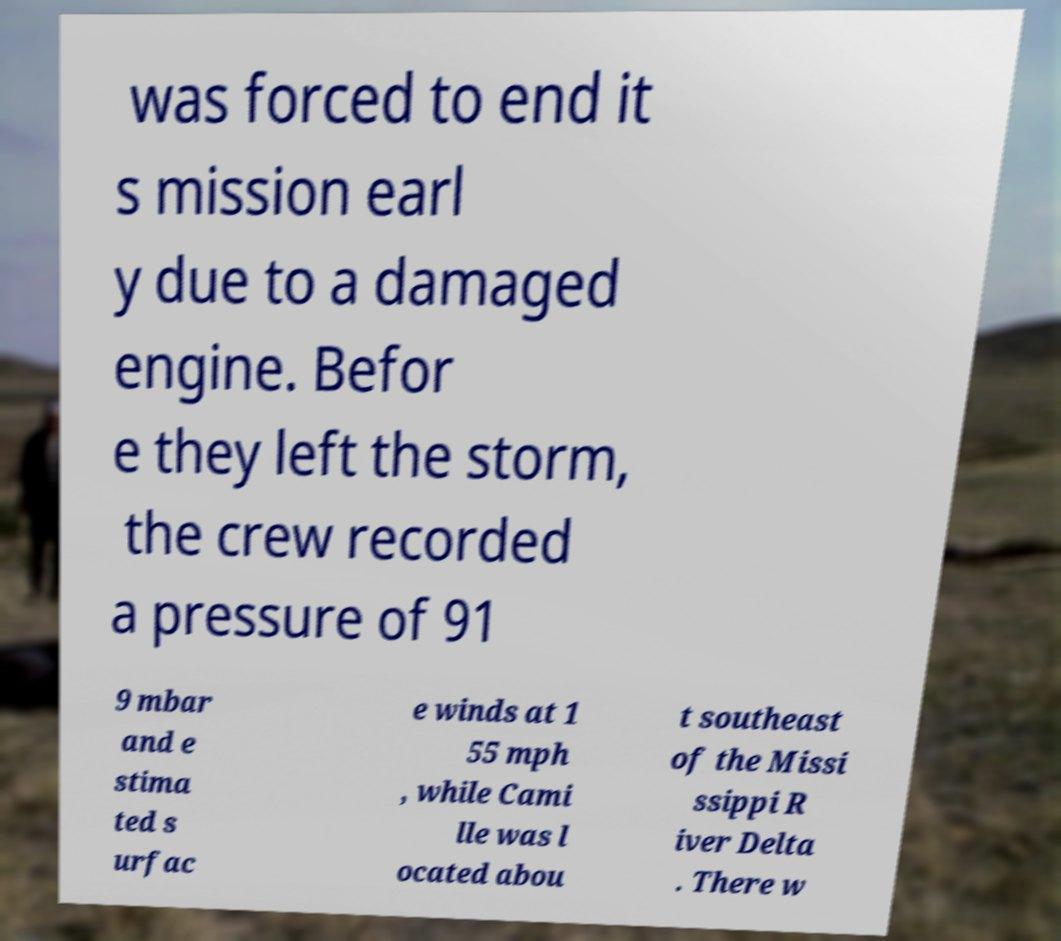Please identify and transcribe the text found in this image. was forced to end it s mission earl y due to a damaged engine. Befor e they left the storm, the crew recorded a pressure of 91 9 mbar and e stima ted s urfac e winds at 1 55 mph , while Cami lle was l ocated abou t southeast of the Missi ssippi R iver Delta . There w 